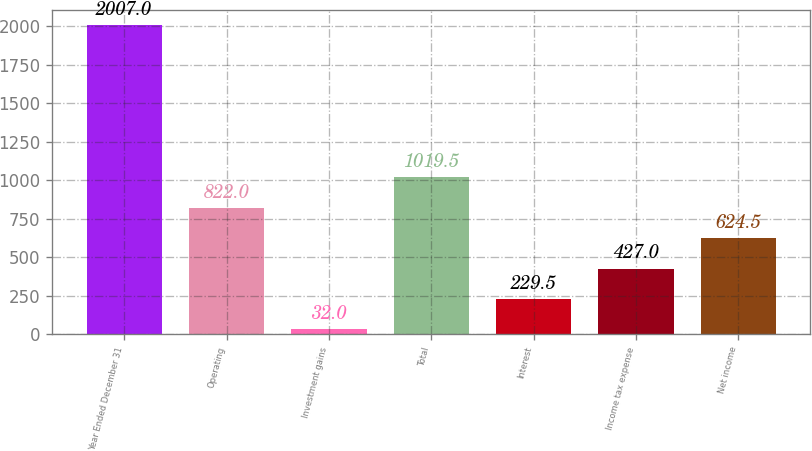Convert chart to OTSL. <chart><loc_0><loc_0><loc_500><loc_500><bar_chart><fcel>Year Ended December 31<fcel>Operating<fcel>Investment gains<fcel>Total<fcel>Interest<fcel>Income tax expense<fcel>Net income<nl><fcel>2007<fcel>822<fcel>32<fcel>1019.5<fcel>229.5<fcel>427<fcel>624.5<nl></chart> 